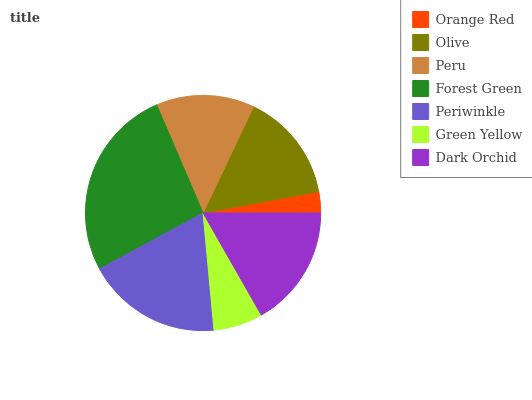Is Orange Red the minimum?
Answer yes or no. Yes. Is Forest Green the maximum?
Answer yes or no. Yes. Is Olive the minimum?
Answer yes or no. No. Is Olive the maximum?
Answer yes or no. No. Is Olive greater than Orange Red?
Answer yes or no. Yes. Is Orange Red less than Olive?
Answer yes or no. Yes. Is Orange Red greater than Olive?
Answer yes or no. No. Is Olive less than Orange Red?
Answer yes or no. No. Is Olive the high median?
Answer yes or no. Yes. Is Olive the low median?
Answer yes or no. Yes. Is Dark Orchid the high median?
Answer yes or no. No. Is Dark Orchid the low median?
Answer yes or no. No. 